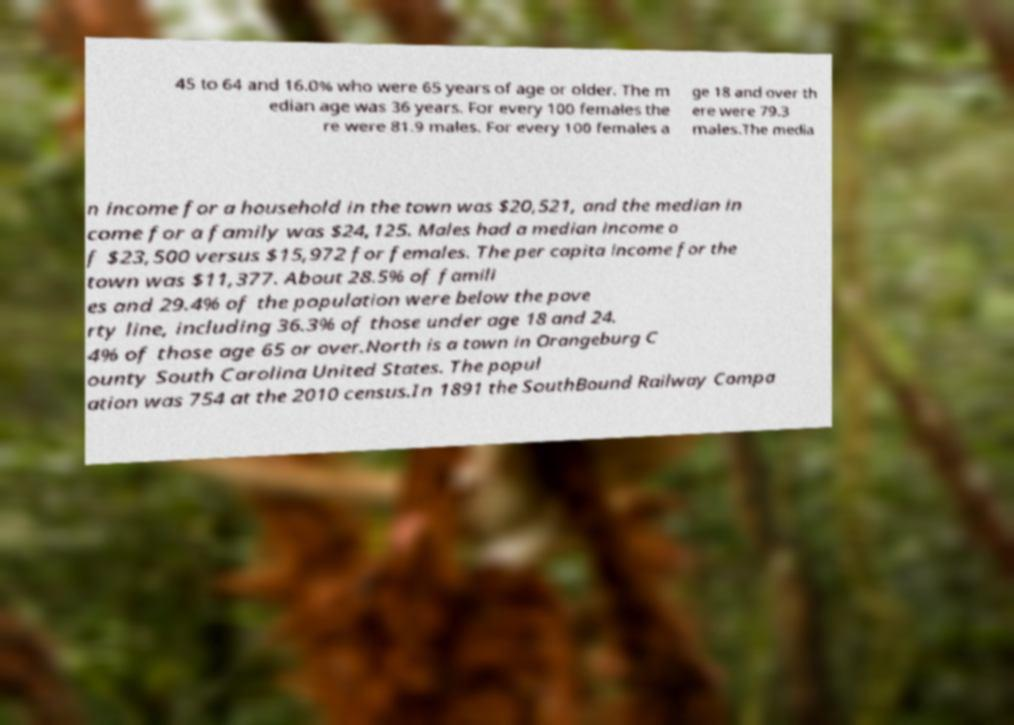For documentation purposes, I need the text within this image transcribed. Could you provide that? 45 to 64 and 16.0% who were 65 years of age or older. The m edian age was 36 years. For every 100 females the re were 81.9 males. For every 100 females a ge 18 and over th ere were 79.3 males.The media n income for a household in the town was $20,521, and the median in come for a family was $24,125. Males had a median income o f $23,500 versus $15,972 for females. The per capita income for the town was $11,377. About 28.5% of famili es and 29.4% of the population were below the pove rty line, including 36.3% of those under age 18 and 24. 4% of those age 65 or over.North is a town in Orangeburg C ounty South Carolina United States. The popul ation was 754 at the 2010 census.In 1891 the SouthBound Railway Compa 